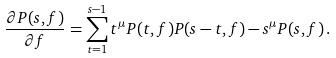<formula> <loc_0><loc_0><loc_500><loc_500>\frac { \partial P ( s , f ) } { \partial f } = \sum _ { t = 1 } ^ { s - 1 } t ^ { \mu } P ( t , f ) P ( s - t , f ) - s ^ { \mu } P ( s , f ) \, .</formula> 